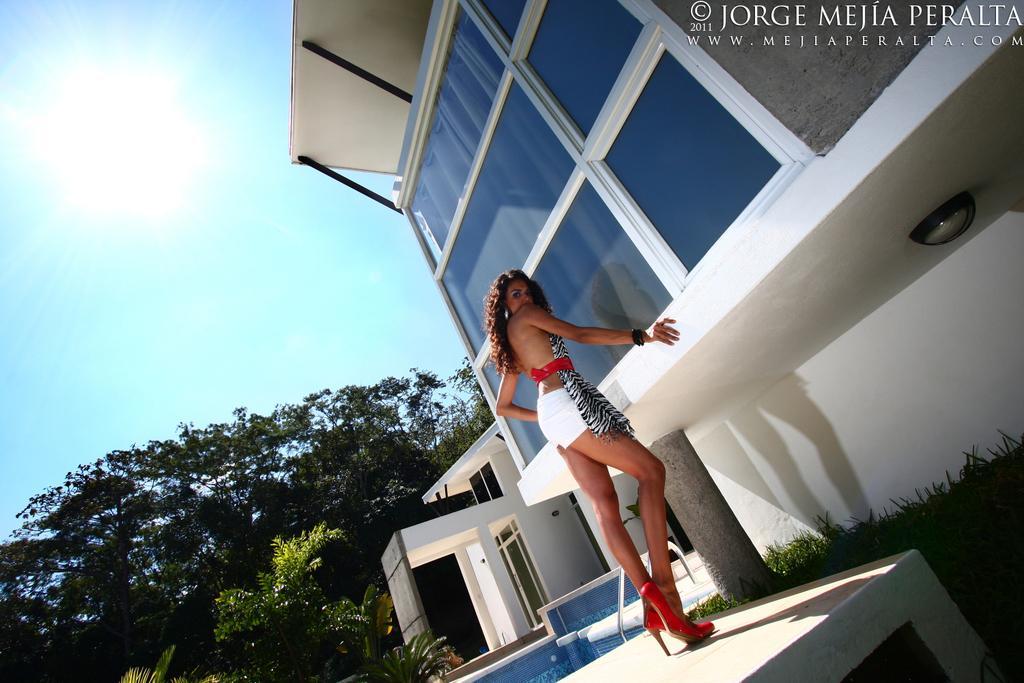Please provide a concise description of this image. In this picture there is a girl in the center of the image and there is a building at the top side of the image, there are trees on the left side of the image. 